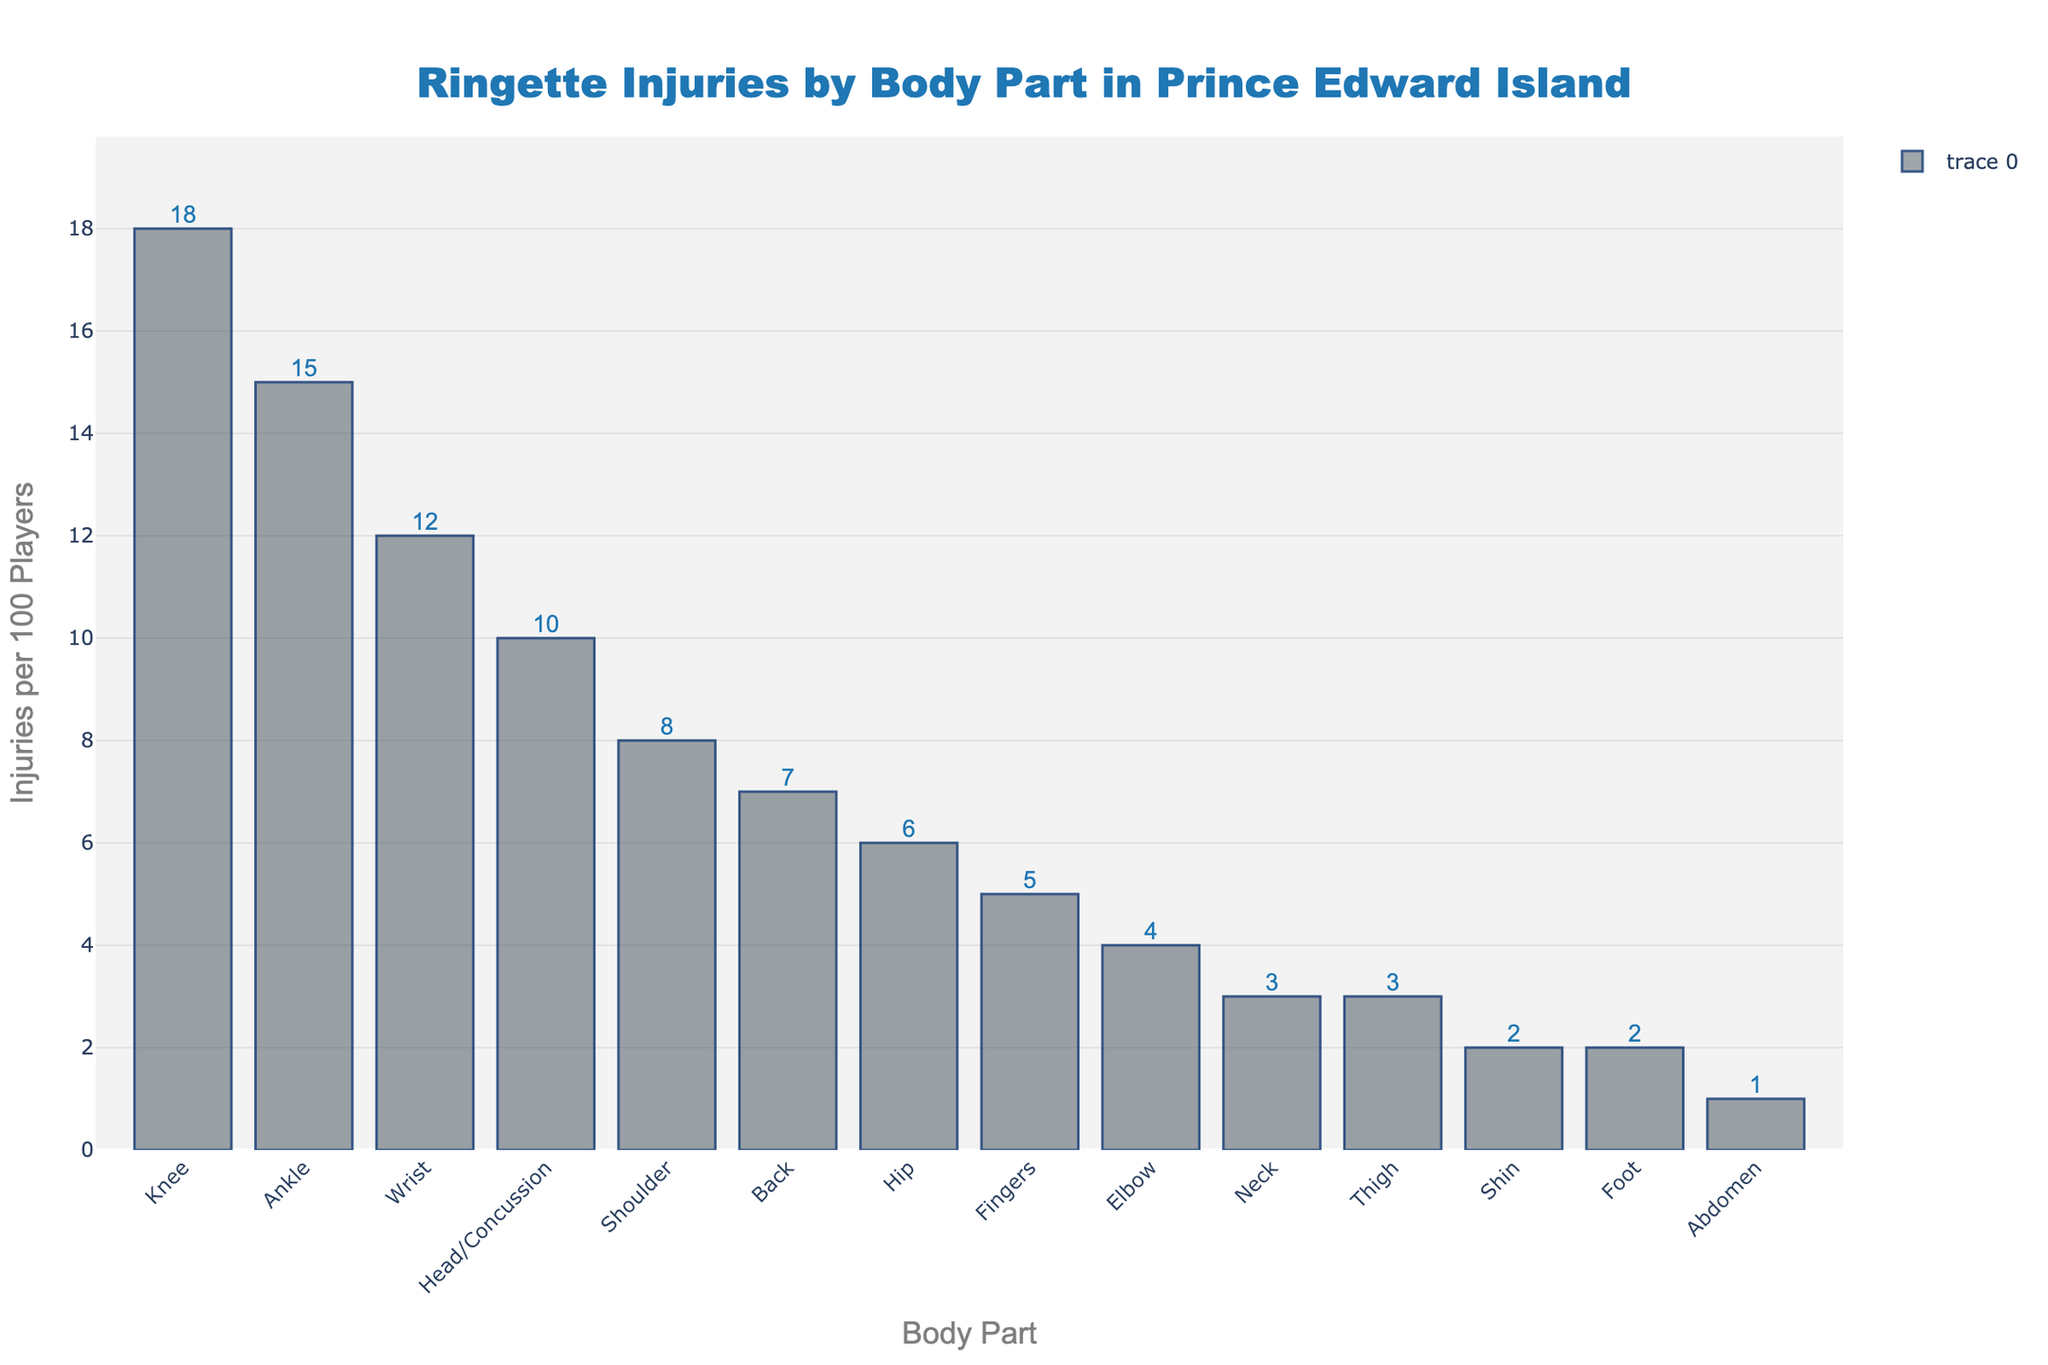What is the most common injury type among ringette players in Prince Edward Island? The tallest bar represents the body part with the highest injury frequency. The highest is "Knee" with 18 injuries per 100 players.
Answer: Knee Which body parts have an equal number of injuries per 100 players? By comparing bar heights, "Neck" and "Thigh" are equal, both with 3 injuries per 100 players. "Shin" and "Foot" are also equal, both with 2 injuries per 100 players.
Answer: Neck and Thigh; Shin and Foot What is the difference in injury frequency between the knee and the ankle? The knee has 18 injuries per 100 players, and the ankle has 15. The difference is 18 - 15 = 3.
Answer: 3 What is the total number of injuries per 100 players for the top three most common injury types? Sum the injuries for the knee (18), ankle (15), and wrist (12): 18 + 15 + 12 = 45.
Answer: 45 How many body parts have more than 10 injuries per 100 players? The bars for knee, ankle, and wrist are above the 10 injury threshold. There are 3 such body parts.
Answer: 3 Which body part has the least number of injuries, and how many? The shortest bar represents abdomen, with 1 injury per 100 players.
Answer: Abdomen, 1 What is the average number of injuries per 100 players across all recorded body parts? Sum all injuries (18, 15, 12, 10, 8, 7, 6, 5, 4, 3, 3, 2, 2, 1) = 96. There are 14 body parts. The average is 96 / 14 ≈ 6.86.
Answer: 6.86 Compare the injury frequency between the wrist and the hip. Which is higher and by how much? The wrist has 12 injuries, and the hip has 6. The difference is 12 - 6 = 6. The wrist has 6 more injuries than the hip.
Answer: Wrist by 6 What is the combined injury frequency for the upper body parts (head, shoulder, back, neck, and elbow)? Sum the injuries for head (10), shoulder (8), back (7), neck (3), and elbow (4): 10 + 8 + 7 + 3 + 4 = 32.
Answer: 32 Which body part categories have fewer than 5 injuries per 100 players? The bars for elbow, neck, thigh, shin, foot, and abdomen are below the 5 injury threshold.
Answer: Elbow, Neck, Thigh, Shin, Foot, Abdomen 